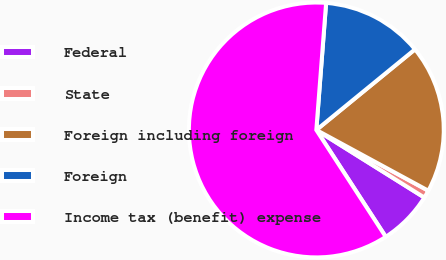Convert chart. <chart><loc_0><loc_0><loc_500><loc_500><pie_chart><fcel>Federal<fcel>State<fcel>Foreign including foreign<fcel>Foreign<fcel>Income tax (benefit) expense<nl><fcel>6.93%<fcel>0.99%<fcel>18.81%<fcel>12.87%<fcel>60.39%<nl></chart> 